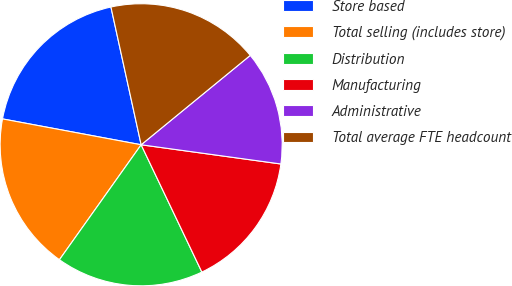Convert chart to OTSL. <chart><loc_0><loc_0><loc_500><loc_500><pie_chart><fcel>Store based<fcel>Total selling (includes store)<fcel>Distribution<fcel>Manufacturing<fcel>Administrative<fcel>Total average FTE headcount<nl><fcel>18.63%<fcel>18.1%<fcel>16.92%<fcel>15.74%<fcel>13.1%<fcel>17.51%<nl></chart> 